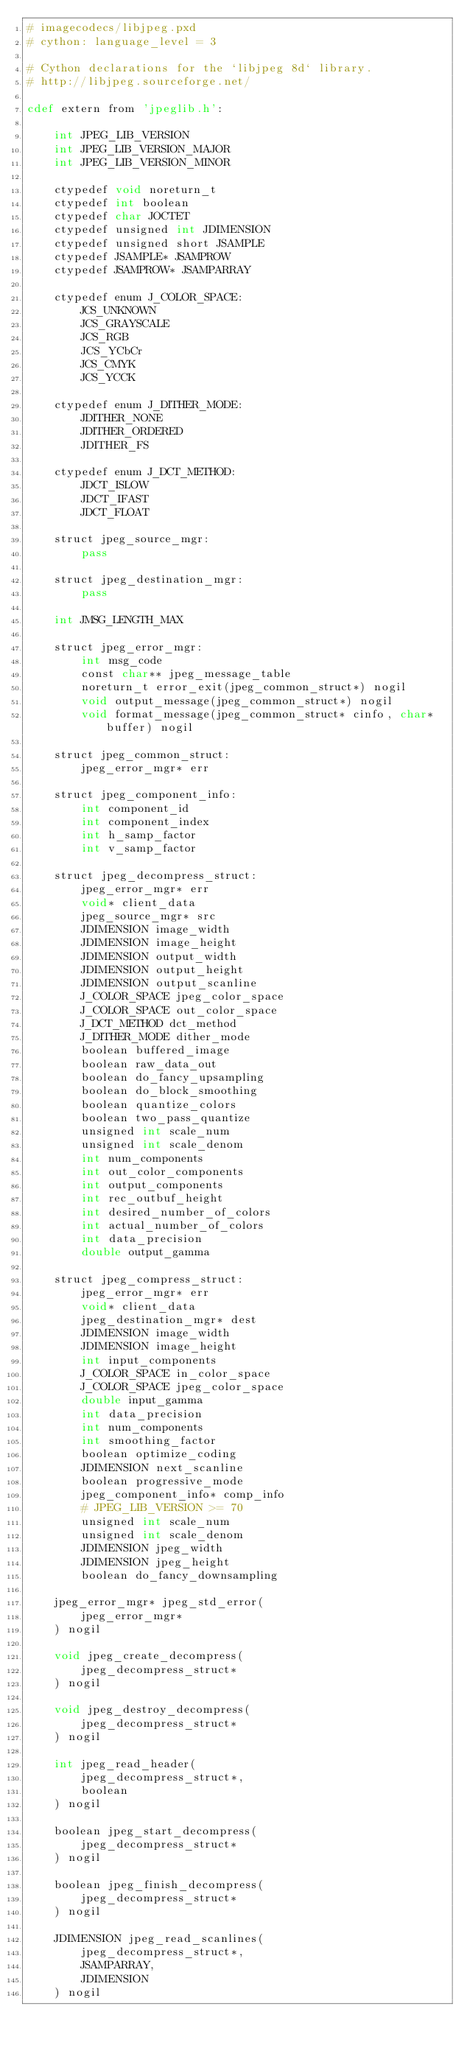Convert code to text. <code><loc_0><loc_0><loc_500><loc_500><_Cython_># imagecodecs/libjpeg.pxd
# cython: language_level = 3

# Cython declarations for the `libjpeg 8d` library.
# http://libjpeg.sourceforge.net/

cdef extern from 'jpeglib.h':

    int JPEG_LIB_VERSION
    int JPEG_LIB_VERSION_MAJOR
    int JPEG_LIB_VERSION_MINOR

    ctypedef void noreturn_t
    ctypedef int boolean
    ctypedef char JOCTET
    ctypedef unsigned int JDIMENSION
    ctypedef unsigned short JSAMPLE
    ctypedef JSAMPLE* JSAMPROW
    ctypedef JSAMPROW* JSAMPARRAY

    ctypedef enum J_COLOR_SPACE:
        JCS_UNKNOWN
        JCS_GRAYSCALE
        JCS_RGB
        JCS_YCbCr
        JCS_CMYK
        JCS_YCCK

    ctypedef enum J_DITHER_MODE:
        JDITHER_NONE
        JDITHER_ORDERED
        JDITHER_FS

    ctypedef enum J_DCT_METHOD:
        JDCT_ISLOW
        JDCT_IFAST
        JDCT_FLOAT

    struct jpeg_source_mgr:
        pass

    struct jpeg_destination_mgr:
        pass

    int JMSG_LENGTH_MAX

    struct jpeg_error_mgr:
        int msg_code
        const char** jpeg_message_table
        noreturn_t error_exit(jpeg_common_struct*) nogil
        void output_message(jpeg_common_struct*) nogil
        void format_message(jpeg_common_struct* cinfo, char* buffer) nogil

    struct jpeg_common_struct:
        jpeg_error_mgr* err

    struct jpeg_component_info:
        int component_id
        int component_index
        int h_samp_factor
        int v_samp_factor

    struct jpeg_decompress_struct:
        jpeg_error_mgr* err
        void* client_data
        jpeg_source_mgr* src
        JDIMENSION image_width
        JDIMENSION image_height
        JDIMENSION output_width
        JDIMENSION output_height
        JDIMENSION output_scanline
        J_COLOR_SPACE jpeg_color_space
        J_COLOR_SPACE out_color_space
        J_DCT_METHOD dct_method
        J_DITHER_MODE dither_mode
        boolean buffered_image
        boolean raw_data_out
        boolean do_fancy_upsampling
        boolean do_block_smoothing
        boolean quantize_colors
        boolean two_pass_quantize
        unsigned int scale_num
        unsigned int scale_denom
        int num_components
        int out_color_components
        int output_components
        int rec_outbuf_height
        int desired_number_of_colors
        int actual_number_of_colors
        int data_precision
        double output_gamma

    struct jpeg_compress_struct:
        jpeg_error_mgr* err
        void* client_data
        jpeg_destination_mgr* dest
        JDIMENSION image_width
        JDIMENSION image_height
        int input_components
        J_COLOR_SPACE in_color_space
        J_COLOR_SPACE jpeg_color_space
        double input_gamma
        int data_precision
        int num_components
        int smoothing_factor
        boolean optimize_coding
        JDIMENSION next_scanline
        boolean progressive_mode
        jpeg_component_info* comp_info
        # JPEG_LIB_VERSION >= 70
        unsigned int scale_num
        unsigned int scale_denom
        JDIMENSION jpeg_width
        JDIMENSION jpeg_height
        boolean do_fancy_downsampling

    jpeg_error_mgr* jpeg_std_error(
        jpeg_error_mgr*
    ) nogil

    void jpeg_create_decompress(
        jpeg_decompress_struct*
    ) nogil

    void jpeg_destroy_decompress(
        jpeg_decompress_struct*
    ) nogil

    int jpeg_read_header(
        jpeg_decompress_struct*,
        boolean
    ) nogil

    boolean jpeg_start_decompress(
        jpeg_decompress_struct*
    ) nogil

    boolean jpeg_finish_decompress(
        jpeg_decompress_struct*
    ) nogil

    JDIMENSION jpeg_read_scanlines(
        jpeg_decompress_struct*,
        JSAMPARRAY,
        JDIMENSION
    ) nogil
</code> 